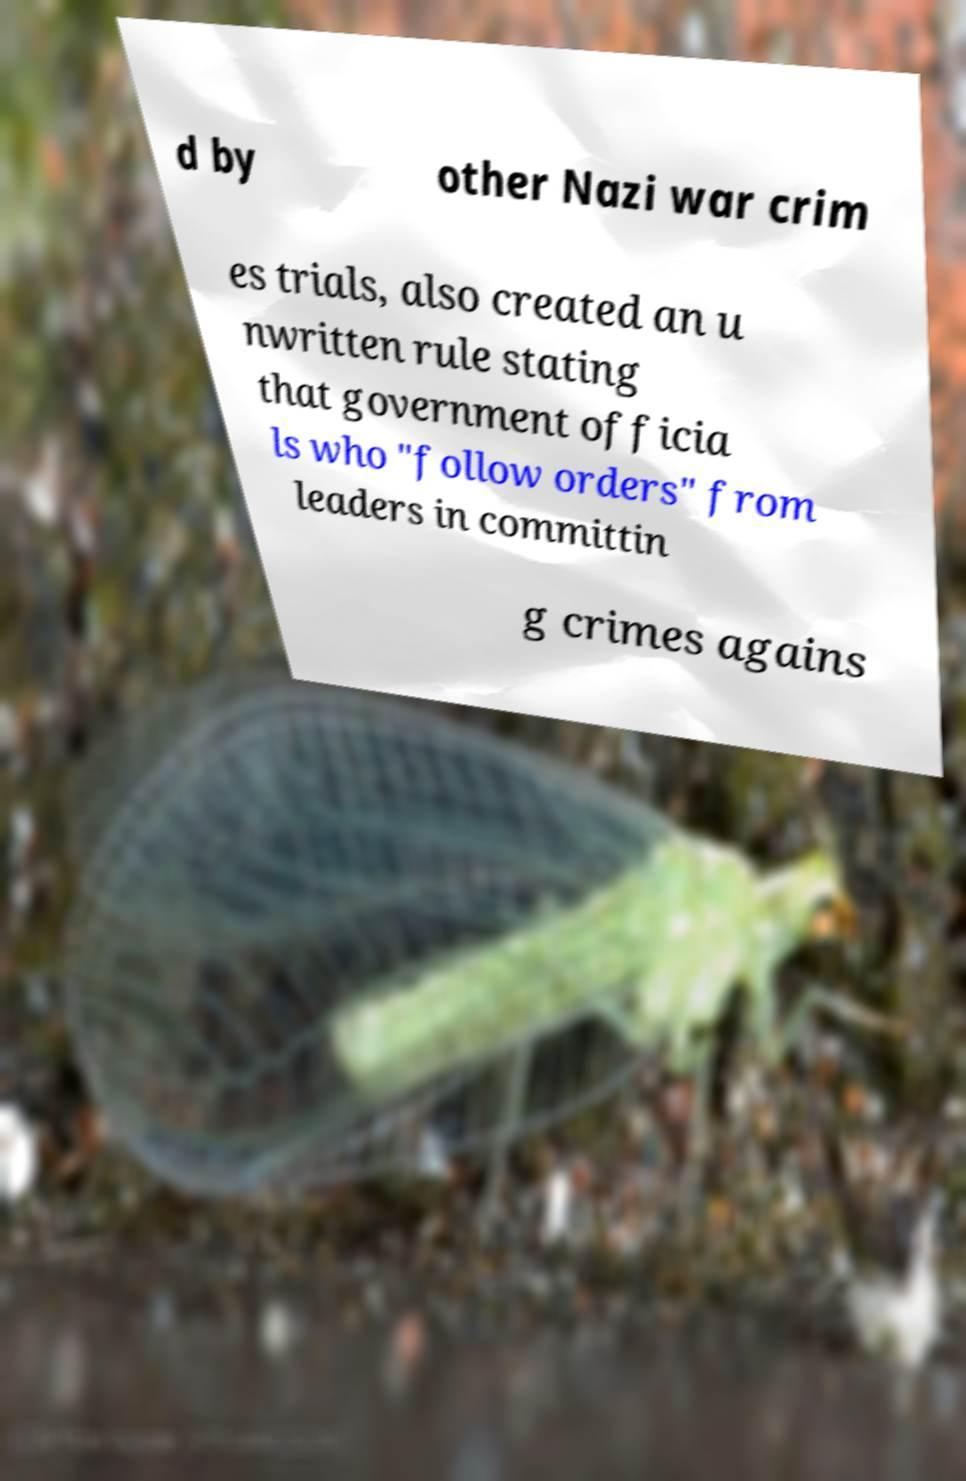I need the written content from this picture converted into text. Can you do that? d by other Nazi war crim es trials, also created an u nwritten rule stating that government officia ls who "follow orders" from leaders in committin g crimes agains 